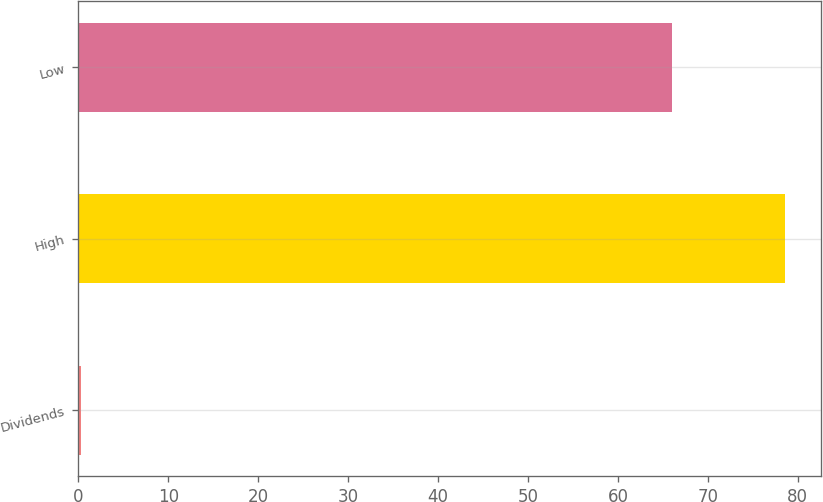Convert chart to OTSL. <chart><loc_0><loc_0><loc_500><loc_500><bar_chart><fcel>Dividends<fcel>High<fcel>Low<nl><fcel>0.33<fcel>78.61<fcel>65.99<nl></chart> 